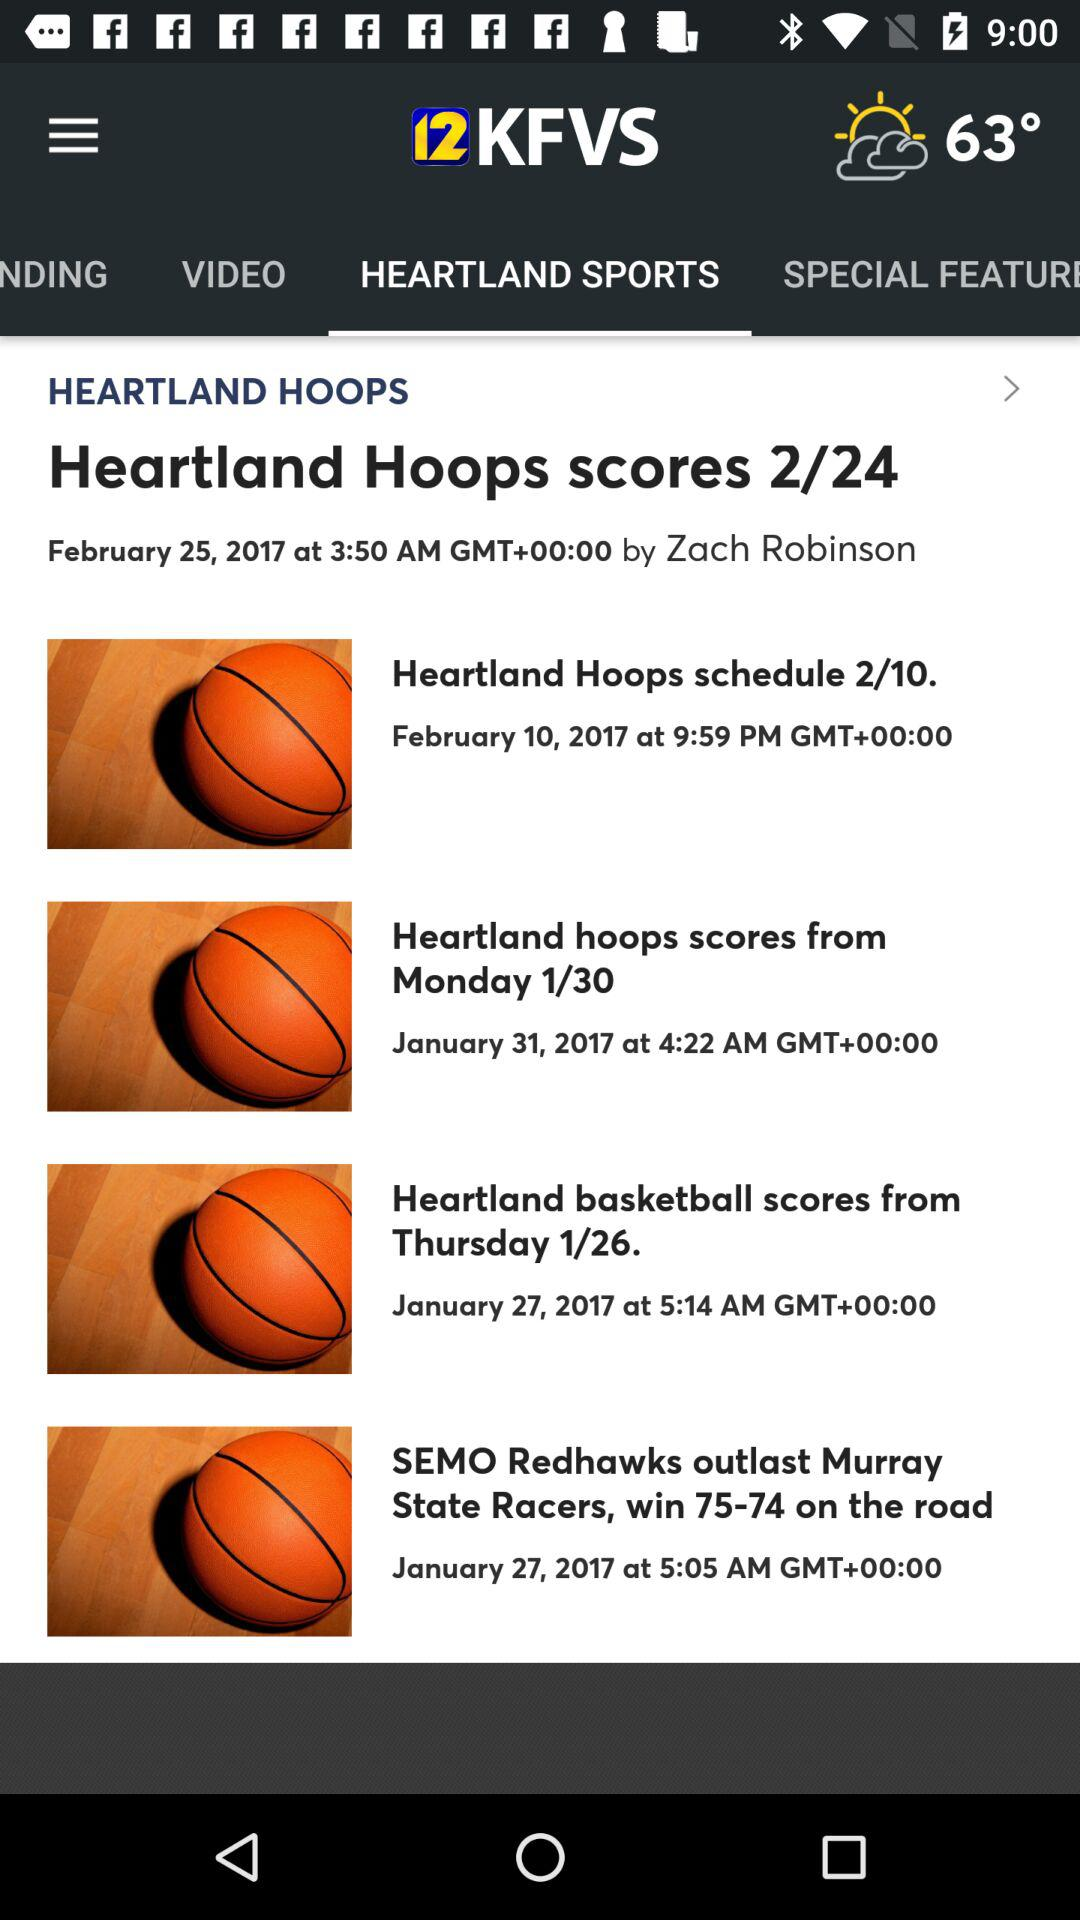What is the posted date of "Heartland Hoops scores 2/24"? The posted date is February 25, 2017. 